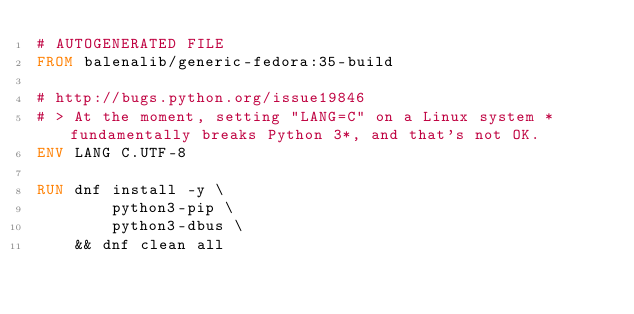Convert code to text. <code><loc_0><loc_0><loc_500><loc_500><_Dockerfile_># AUTOGENERATED FILE
FROM balenalib/generic-fedora:35-build

# http://bugs.python.org/issue19846
# > At the moment, setting "LANG=C" on a Linux system *fundamentally breaks Python 3*, and that's not OK.
ENV LANG C.UTF-8

RUN dnf install -y \
		python3-pip \
		python3-dbus \
	&& dnf clean all
</code> 